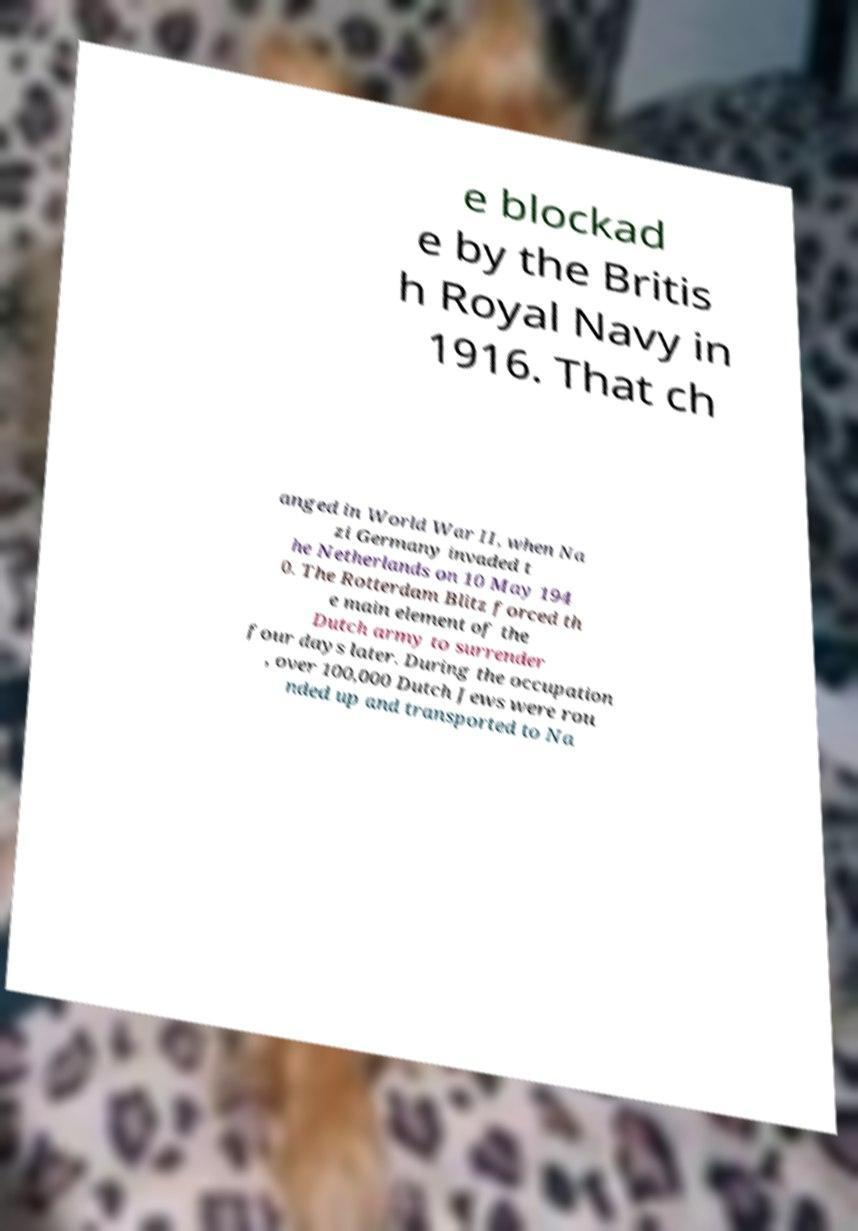Please read and relay the text visible in this image. What does it say? e blockad e by the Britis h Royal Navy in 1916. That ch anged in World War II, when Na zi Germany invaded t he Netherlands on 10 May 194 0. The Rotterdam Blitz forced th e main element of the Dutch army to surrender four days later. During the occupation , over 100,000 Dutch Jews were rou nded up and transported to Na 